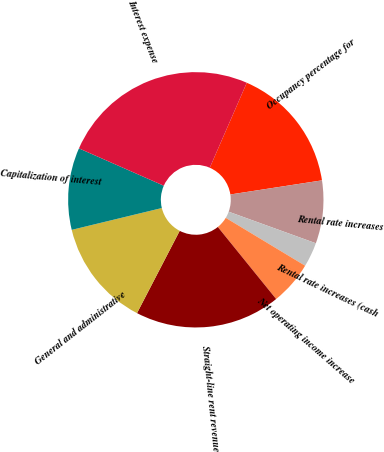Convert chart to OTSL. <chart><loc_0><loc_0><loc_500><loc_500><pie_chart><fcel>Occupancy percentage for<fcel>Rental rate increases<fcel>Rental rate increases (cash<fcel>Net operating income increase<fcel>Straight-line rent revenue<fcel>General and administrative<fcel>Capitalization of interest<fcel>Interest expense<nl><fcel>16.03%<fcel>7.96%<fcel>3.11%<fcel>5.53%<fcel>18.45%<fcel>13.6%<fcel>10.38%<fcel>24.94%<nl></chart> 